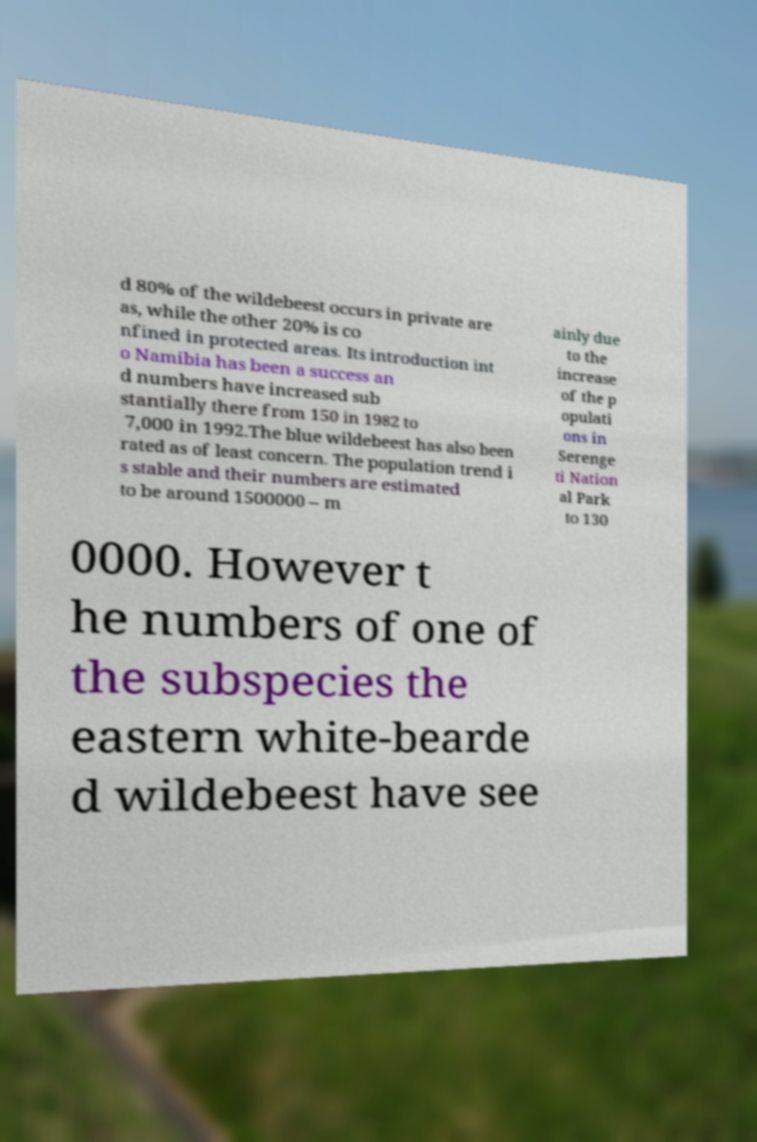Could you extract and type out the text from this image? d 80% of the wildebeest occurs in private are as, while the other 20% is co nfined in protected areas. Its introduction int o Namibia has been a success an d numbers have increased sub stantially there from 150 in 1982 to 7,000 in 1992.The blue wildebeest has also been rated as of least concern. The population trend i s stable and their numbers are estimated to be around 1500000 – m ainly due to the increase of the p opulati ons in Serenge ti Nation al Park to 130 0000. However t he numbers of one of the subspecies the eastern white-bearde d wildebeest have see 